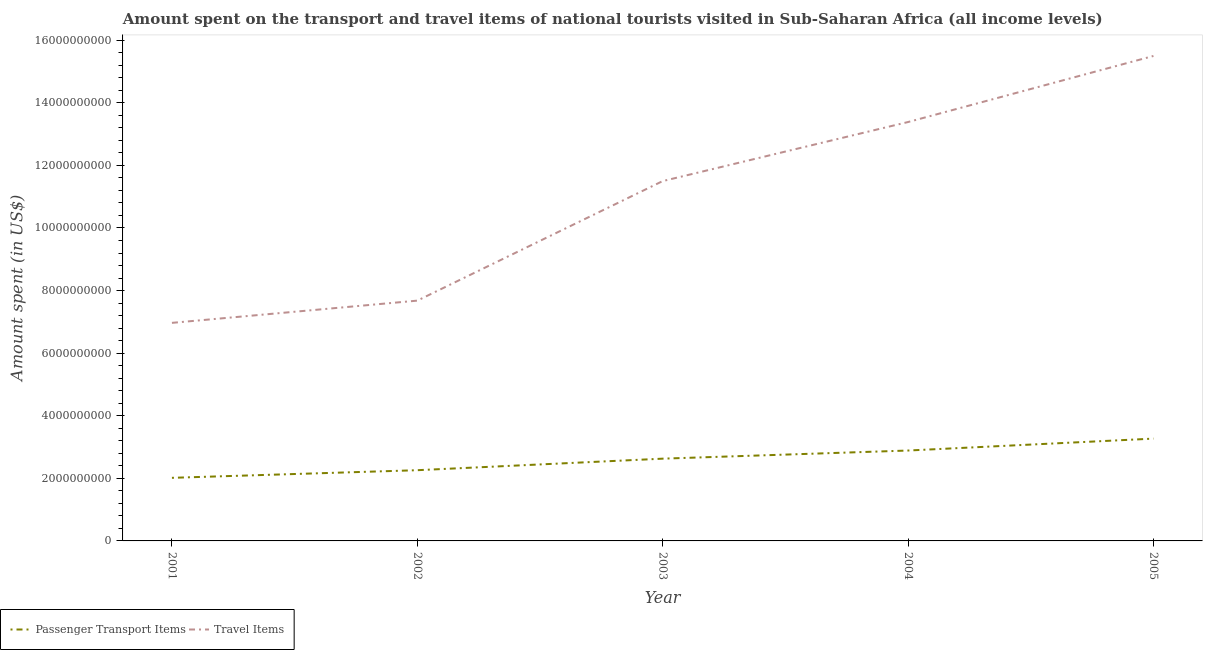How many different coloured lines are there?
Provide a short and direct response. 2. What is the amount spent in travel items in 2003?
Ensure brevity in your answer.  1.15e+1. Across all years, what is the maximum amount spent in travel items?
Provide a short and direct response. 1.55e+1. Across all years, what is the minimum amount spent in travel items?
Provide a short and direct response. 6.97e+09. What is the total amount spent in travel items in the graph?
Provide a short and direct response. 5.50e+1. What is the difference between the amount spent on passenger transport items in 2001 and that in 2002?
Make the answer very short. -2.44e+08. What is the difference between the amount spent in travel items in 2005 and the amount spent on passenger transport items in 2001?
Provide a succinct answer. 1.35e+1. What is the average amount spent on passenger transport items per year?
Give a very brief answer. 2.61e+09. In the year 2003, what is the difference between the amount spent on passenger transport items and amount spent in travel items?
Provide a short and direct response. -8.87e+09. In how many years, is the amount spent on passenger transport items greater than 12400000000 US$?
Give a very brief answer. 0. What is the ratio of the amount spent on passenger transport items in 2003 to that in 2004?
Ensure brevity in your answer.  0.91. What is the difference between the highest and the second highest amount spent in travel items?
Give a very brief answer. 2.11e+09. What is the difference between the highest and the lowest amount spent in travel items?
Your answer should be compact. 8.53e+09. In how many years, is the amount spent on passenger transport items greater than the average amount spent on passenger transport items taken over all years?
Your response must be concise. 3. Is the amount spent in travel items strictly less than the amount spent on passenger transport items over the years?
Ensure brevity in your answer.  No. How many years are there in the graph?
Offer a terse response. 5. Are the values on the major ticks of Y-axis written in scientific E-notation?
Provide a short and direct response. No. Does the graph contain any zero values?
Provide a succinct answer. No. Where does the legend appear in the graph?
Give a very brief answer. Bottom left. How many legend labels are there?
Your answer should be very brief. 2. What is the title of the graph?
Make the answer very short. Amount spent on the transport and travel items of national tourists visited in Sub-Saharan Africa (all income levels). Does "Private credit bureau" appear as one of the legend labels in the graph?
Your answer should be compact. No. What is the label or title of the Y-axis?
Offer a very short reply. Amount spent (in US$). What is the Amount spent (in US$) in Passenger Transport Items in 2001?
Provide a succinct answer. 2.02e+09. What is the Amount spent (in US$) in Travel Items in 2001?
Provide a succinct answer. 6.97e+09. What is the Amount spent (in US$) in Passenger Transport Items in 2002?
Your response must be concise. 2.26e+09. What is the Amount spent (in US$) of Travel Items in 2002?
Offer a terse response. 7.68e+09. What is the Amount spent (in US$) of Passenger Transport Items in 2003?
Make the answer very short. 2.63e+09. What is the Amount spent (in US$) of Travel Items in 2003?
Your answer should be compact. 1.15e+1. What is the Amount spent (in US$) in Passenger Transport Items in 2004?
Your answer should be compact. 2.89e+09. What is the Amount spent (in US$) of Travel Items in 2004?
Your answer should be compact. 1.34e+1. What is the Amount spent (in US$) of Passenger Transport Items in 2005?
Make the answer very short. 3.27e+09. What is the Amount spent (in US$) of Travel Items in 2005?
Offer a very short reply. 1.55e+1. Across all years, what is the maximum Amount spent (in US$) of Passenger Transport Items?
Ensure brevity in your answer.  3.27e+09. Across all years, what is the maximum Amount spent (in US$) of Travel Items?
Your answer should be compact. 1.55e+1. Across all years, what is the minimum Amount spent (in US$) in Passenger Transport Items?
Make the answer very short. 2.02e+09. Across all years, what is the minimum Amount spent (in US$) of Travel Items?
Give a very brief answer. 6.97e+09. What is the total Amount spent (in US$) of Passenger Transport Items in the graph?
Offer a terse response. 1.31e+1. What is the total Amount spent (in US$) in Travel Items in the graph?
Your answer should be compact. 5.50e+1. What is the difference between the Amount spent (in US$) of Passenger Transport Items in 2001 and that in 2002?
Keep it short and to the point. -2.44e+08. What is the difference between the Amount spent (in US$) of Travel Items in 2001 and that in 2002?
Provide a short and direct response. -7.10e+08. What is the difference between the Amount spent (in US$) of Passenger Transport Items in 2001 and that in 2003?
Provide a short and direct response. -6.12e+08. What is the difference between the Amount spent (in US$) of Travel Items in 2001 and that in 2003?
Provide a succinct answer. -4.53e+09. What is the difference between the Amount spent (in US$) in Passenger Transport Items in 2001 and that in 2004?
Make the answer very short. -8.72e+08. What is the difference between the Amount spent (in US$) of Travel Items in 2001 and that in 2004?
Provide a succinct answer. -6.42e+09. What is the difference between the Amount spent (in US$) in Passenger Transport Items in 2001 and that in 2005?
Ensure brevity in your answer.  -1.25e+09. What is the difference between the Amount spent (in US$) of Travel Items in 2001 and that in 2005?
Keep it short and to the point. -8.53e+09. What is the difference between the Amount spent (in US$) in Passenger Transport Items in 2002 and that in 2003?
Give a very brief answer. -3.69e+08. What is the difference between the Amount spent (in US$) of Travel Items in 2002 and that in 2003?
Make the answer very short. -3.82e+09. What is the difference between the Amount spent (in US$) in Passenger Transport Items in 2002 and that in 2004?
Keep it short and to the point. -6.29e+08. What is the difference between the Amount spent (in US$) in Travel Items in 2002 and that in 2004?
Provide a succinct answer. -5.71e+09. What is the difference between the Amount spent (in US$) of Passenger Transport Items in 2002 and that in 2005?
Offer a terse response. -1.01e+09. What is the difference between the Amount spent (in US$) in Travel Items in 2002 and that in 2005?
Offer a very short reply. -7.82e+09. What is the difference between the Amount spent (in US$) of Passenger Transport Items in 2003 and that in 2004?
Keep it short and to the point. -2.60e+08. What is the difference between the Amount spent (in US$) of Travel Items in 2003 and that in 2004?
Your answer should be very brief. -1.89e+09. What is the difference between the Amount spent (in US$) in Passenger Transport Items in 2003 and that in 2005?
Offer a terse response. -6.41e+08. What is the difference between the Amount spent (in US$) of Travel Items in 2003 and that in 2005?
Make the answer very short. -4.00e+09. What is the difference between the Amount spent (in US$) of Passenger Transport Items in 2004 and that in 2005?
Give a very brief answer. -3.81e+08. What is the difference between the Amount spent (in US$) of Travel Items in 2004 and that in 2005?
Provide a short and direct response. -2.11e+09. What is the difference between the Amount spent (in US$) of Passenger Transport Items in 2001 and the Amount spent (in US$) of Travel Items in 2002?
Provide a short and direct response. -5.66e+09. What is the difference between the Amount spent (in US$) in Passenger Transport Items in 2001 and the Amount spent (in US$) in Travel Items in 2003?
Give a very brief answer. -9.48e+09. What is the difference between the Amount spent (in US$) in Passenger Transport Items in 2001 and the Amount spent (in US$) in Travel Items in 2004?
Provide a succinct answer. -1.14e+1. What is the difference between the Amount spent (in US$) in Passenger Transport Items in 2001 and the Amount spent (in US$) in Travel Items in 2005?
Make the answer very short. -1.35e+1. What is the difference between the Amount spent (in US$) of Passenger Transport Items in 2002 and the Amount spent (in US$) of Travel Items in 2003?
Your response must be concise. -9.24e+09. What is the difference between the Amount spent (in US$) of Passenger Transport Items in 2002 and the Amount spent (in US$) of Travel Items in 2004?
Your response must be concise. -1.11e+1. What is the difference between the Amount spent (in US$) in Passenger Transport Items in 2002 and the Amount spent (in US$) in Travel Items in 2005?
Give a very brief answer. -1.32e+1. What is the difference between the Amount spent (in US$) in Passenger Transport Items in 2003 and the Amount spent (in US$) in Travel Items in 2004?
Give a very brief answer. -1.08e+1. What is the difference between the Amount spent (in US$) in Passenger Transport Items in 2003 and the Amount spent (in US$) in Travel Items in 2005?
Give a very brief answer. -1.29e+1. What is the difference between the Amount spent (in US$) of Passenger Transport Items in 2004 and the Amount spent (in US$) of Travel Items in 2005?
Your response must be concise. -1.26e+1. What is the average Amount spent (in US$) of Passenger Transport Items per year?
Ensure brevity in your answer.  2.61e+09. What is the average Amount spent (in US$) of Travel Items per year?
Your answer should be very brief. 1.10e+1. In the year 2001, what is the difference between the Amount spent (in US$) of Passenger Transport Items and Amount spent (in US$) of Travel Items?
Ensure brevity in your answer.  -4.95e+09. In the year 2002, what is the difference between the Amount spent (in US$) in Passenger Transport Items and Amount spent (in US$) in Travel Items?
Offer a very short reply. -5.42e+09. In the year 2003, what is the difference between the Amount spent (in US$) of Passenger Transport Items and Amount spent (in US$) of Travel Items?
Your answer should be very brief. -8.87e+09. In the year 2004, what is the difference between the Amount spent (in US$) in Passenger Transport Items and Amount spent (in US$) in Travel Items?
Provide a short and direct response. -1.05e+1. In the year 2005, what is the difference between the Amount spent (in US$) of Passenger Transport Items and Amount spent (in US$) of Travel Items?
Provide a succinct answer. -1.22e+1. What is the ratio of the Amount spent (in US$) of Passenger Transport Items in 2001 to that in 2002?
Provide a succinct answer. 0.89. What is the ratio of the Amount spent (in US$) in Travel Items in 2001 to that in 2002?
Offer a terse response. 0.91. What is the ratio of the Amount spent (in US$) in Passenger Transport Items in 2001 to that in 2003?
Your answer should be very brief. 0.77. What is the ratio of the Amount spent (in US$) in Travel Items in 2001 to that in 2003?
Offer a terse response. 0.61. What is the ratio of the Amount spent (in US$) of Passenger Transport Items in 2001 to that in 2004?
Offer a very short reply. 0.7. What is the ratio of the Amount spent (in US$) of Travel Items in 2001 to that in 2004?
Your answer should be compact. 0.52. What is the ratio of the Amount spent (in US$) of Passenger Transport Items in 2001 to that in 2005?
Offer a very short reply. 0.62. What is the ratio of the Amount spent (in US$) in Travel Items in 2001 to that in 2005?
Provide a succinct answer. 0.45. What is the ratio of the Amount spent (in US$) of Passenger Transport Items in 2002 to that in 2003?
Offer a very short reply. 0.86. What is the ratio of the Amount spent (in US$) of Travel Items in 2002 to that in 2003?
Ensure brevity in your answer.  0.67. What is the ratio of the Amount spent (in US$) of Passenger Transport Items in 2002 to that in 2004?
Provide a short and direct response. 0.78. What is the ratio of the Amount spent (in US$) of Travel Items in 2002 to that in 2004?
Keep it short and to the point. 0.57. What is the ratio of the Amount spent (in US$) in Passenger Transport Items in 2002 to that in 2005?
Make the answer very short. 0.69. What is the ratio of the Amount spent (in US$) in Travel Items in 2002 to that in 2005?
Your answer should be very brief. 0.5. What is the ratio of the Amount spent (in US$) of Passenger Transport Items in 2003 to that in 2004?
Provide a succinct answer. 0.91. What is the ratio of the Amount spent (in US$) in Travel Items in 2003 to that in 2004?
Your answer should be very brief. 0.86. What is the ratio of the Amount spent (in US$) in Passenger Transport Items in 2003 to that in 2005?
Offer a very short reply. 0.8. What is the ratio of the Amount spent (in US$) of Travel Items in 2003 to that in 2005?
Provide a succinct answer. 0.74. What is the ratio of the Amount spent (in US$) in Passenger Transport Items in 2004 to that in 2005?
Provide a short and direct response. 0.88. What is the ratio of the Amount spent (in US$) in Travel Items in 2004 to that in 2005?
Keep it short and to the point. 0.86. What is the difference between the highest and the second highest Amount spent (in US$) of Passenger Transport Items?
Your answer should be very brief. 3.81e+08. What is the difference between the highest and the second highest Amount spent (in US$) in Travel Items?
Give a very brief answer. 2.11e+09. What is the difference between the highest and the lowest Amount spent (in US$) of Passenger Transport Items?
Your answer should be very brief. 1.25e+09. What is the difference between the highest and the lowest Amount spent (in US$) of Travel Items?
Your answer should be very brief. 8.53e+09. 